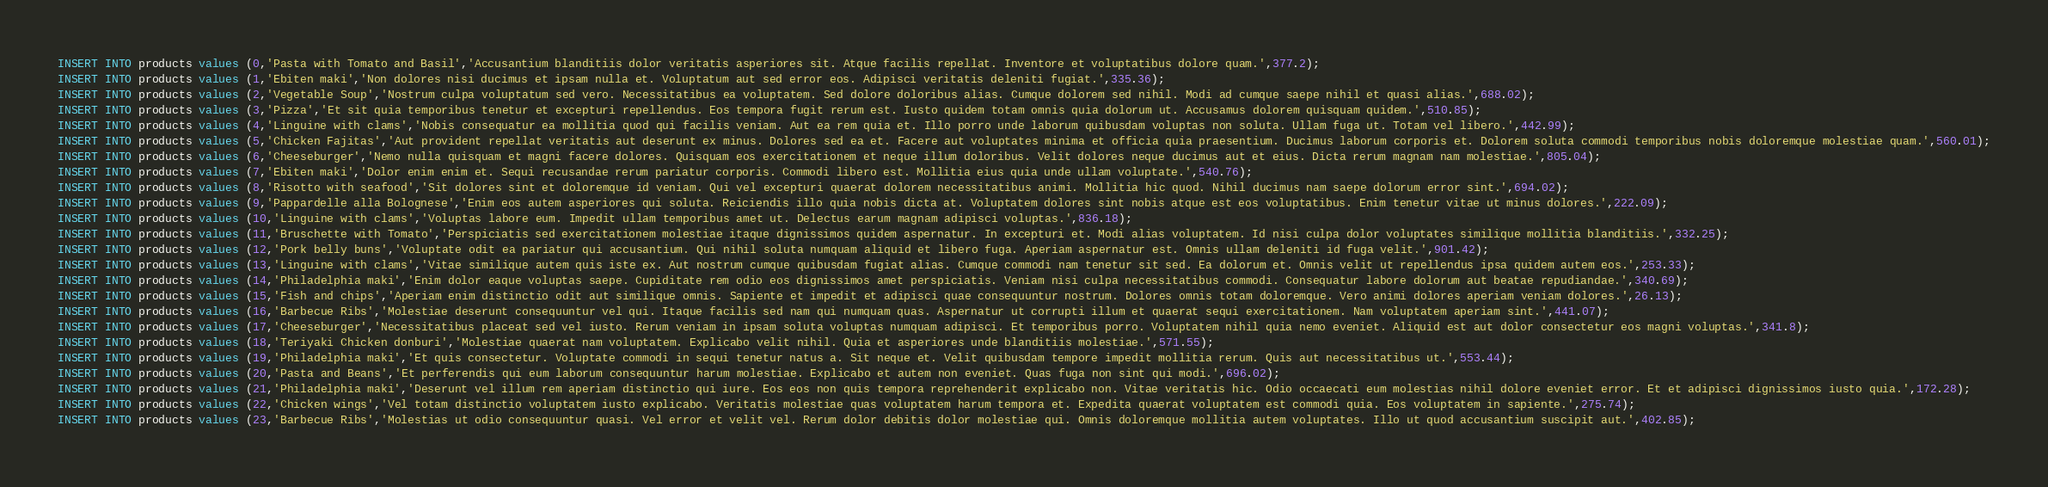<code> <loc_0><loc_0><loc_500><loc_500><_SQL_>INSERT INTO products values (0,'Pasta with Tomato and Basil','Accusantium blanditiis dolor veritatis asperiores sit. Atque facilis repellat. Inventore et voluptatibus dolore quam.',377.2);
INSERT INTO products values (1,'Ebiten maki','Non dolores nisi ducimus et ipsam nulla et. Voluptatum aut sed error eos. Adipisci veritatis deleniti fugiat.',335.36);
INSERT INTO products values (2,'Vegetable Soup','Nostrum culpa voluptatum sed vero. Necessitatibus ea voluptatem. Sed dolore doloribus alias. Cumque dolorem sed nihil. Modi ad cumque saepe nihil et quasi alias.',688.02);
INSERT INTO products values (3,'Pizza','Et sit quia temporibus tenetur et excepturi repellendus. Eos tempora fugit rerum est. Iusto quidem totam omnis quia dolorum ut. Accusamus dolorem quisquam quidem.',510.85);
INSERT INTO products values (4,'Linguine with clams','Nobis consequatur ea mollitia quod qui facilis veniam. Aut ea rem quia et. Illo porro unde laborum quibusdam voluptas non soluta. Ullam fuga ut. Totam vel libero.',442.99);
INSERT INTO products values (5,'Chicken Fajitas','Aut provident repellat veritatis aut deserunt ex minus. Dolores sed ea et. Facere aut voluptates minima et officia quia praesentium. Ducimus laborum corporis et. Dolorem soluta commodi temporibus nobis doloremque molestiae quam.',560.01);
INSERT INTO products values (6,'Cheeseburger','Nemo nulla quisquam et magni facere dolores. Quisquam eos exercitationem et neque illum doloribus. Velit dolores neque ducimus aut et eius. Dicta rerum magnam nam molestiae.',805.04);
INSERT INTO products values (7,'Ebiten maki','Dolor enim enim et. Sequi recusandae rerum pariatur corporis. Commodi libero est. Mollitia eius quia unde ullam voluptate.',540.76);
INSERT INTO products values (8,'Risotto with seafood','Sit dolores sint et doloremque id veniam. Qui vel excepturi quaerat dolorem necessitatibus animi. Mollitia hic quod. Nihil ducimus nam saepe dolorum error sint.',694.02);
INSERT INTO products values (9,'Pappardelle alla Bolognese','Enim eos autem asperiores qui soluta. Reiciendis illo quia nobis dicta at. Voluptatem dolores sint nobis atque est eos voluptatibus. Enim tenetur vitae ut minus dolores.',222.09);
INSERT INTO products values (10,'Linguine with clams','Voluptas labore eum. Impedit ullam temporibus amet ut. Delectus earum magnam adipisci voluptas.',836.18);
INSERT INTO products values (11,'Bruschette with Tomato','Perspiciatis sed exercitationem molestiae itaque dignissimos quidem aspernatur. In excepturi et. Modi alias voluptatem. Id nisi culpa dolor voluptates similique mollitia blanditiis.',332.25);
INSERT INTO products values (12,'Pork belly buns','Voluptate odit ea pariatur qui accusantium. Qui nihil soluta numquam aliquid et libero fuga. Aperiam aspernatur est. Omnis ullam deleniti id fuga velit.',901.42);
INSERT INTO products values (13,'Linguine with clams','Vitae similique autem quis iste ex. Aut nostrum cumque quibusdam fugiat alias. Cumque commodi nam tenetur sit sed. Ea dolorum et. Omnis velit ut repellendus ipsa quidem autem eos.',253.33);
INSERT INTO products values (14,'Philadelphia maki','Enim dolor eaque voluptas saepe. Cupiditate rem odio eos dignissimos amet perspiciatis. Veniam nisi culpa necessitatibus commodi. Consequatur labore dolorum aut beatae repudiandae.',340.69);
INSERT INTO products values (15,'Fish and chips','Aperiam enim distinctio odit aut similique omnis. Sapiente et impedit et adipisci quae consequuntur nostrum. Dolores omnis totam doloremque. Vero animi dolores aperiam veniam dolores.',26.13);
INSERT INTO products values (16,'Barbecue Ribs','Molestiae deserunt consequuntur vel qui. Itaque facilis sed nam qui numquam quas. Aspernatur ut corrupti illum et quaerat sequi exercitationem. Nam voluptatem aperiam sint.',441.07);
INSERT INTO products values (17,'Cheeseburger','Necessitatibus placeat sed vel iusto. Rerum veniam in ipsam soluta voluptas numquam adipisci. Et temporibus porro. Voluptatem nihil quia nemo eveniet. Aliquid est aut dolor consectetur eos magni voluptas.',341.8);
INSERT INTO products values (18,'Teriyaki Chicken donburi','Molestiae quaerat nam voluptatem. Explicabo velit nihil. Quia et asperiores unde blanditiis molestiae.',571.55);
INSERT INTO products values (19,'Philadelphia maki','Et quis consectetur. Voluptate commodi in sequi tenetur natus a. Sit neque et. Velit quibusdam tempore impedit mollitia rerum. Quis aut necessitatibus ut.',553.44);
INSERT INTO products values (20,'Pasta and Beans','Et perferendis qui eum laborum consequuntur harum molestiae. Explicabo et autem non eveniet. Quas fuga non sint qui modi.',696.02);
INSERT INTO products values (21,'Philadelphia maki','Deserunt vel illum rem aperiam distinctio qui iure. Eos eos non quis tempora reprehenderit explicabo non. Vitae veritatis hic. Odio occaecati eum molestias nihil dolore eveniet error. Et et adipisci dignissimos iusto quia.',172.28);
INSERT INTO products values (22,'Chicken wings','Vel totam distinctio voluptatem iusto explicabo. Veritatis molestiae quas voluptatem harum tempora et. Expedita quaerat voluptatem est commodi quia. Eos voluptatem in sapiente.',275.74);
INSERT INTO products values (23,'Barbecue Ribs','Molestias ut odio consequuntur quasi. Vel error et velit vel. Rerum dolor debitis dolor molestiae qui. Omnis doloremque mollitia autem voluptates. Illo ut quod accusantium suscipit aut.',402.85);</code> 